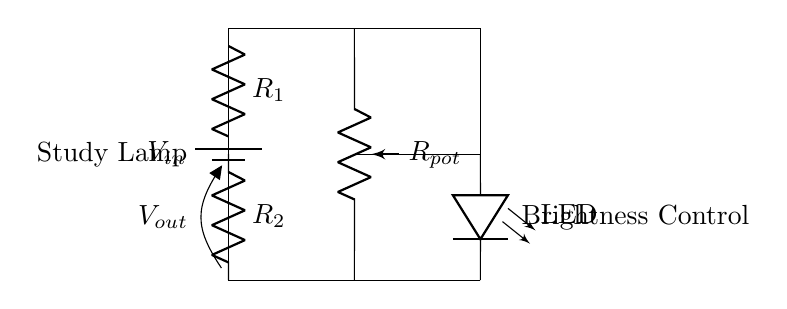What are the resistors in the circuit? The circuit contains two resistors, named R1 and R2, indicated in the diagram.
Answer: R1, R2 What is the role of the potentiometer in this circuit? The potentiometer, labeled Rpot, allows for adjustable resistance, which helps control the brightness of the LED.
Answer: Brightness control What is the output voltage related to? The output voltage, labeled Vout, is the voltage drop across resistor R2 and affects the LED brightness.
Answer: LED brightness How is the LED connected to the circuit? The LED is directly connected to the output of resistor R2, where it receives the adjusted voltage from Vout.
Answer: Parallel What happens if R1 is increased? Increasing R1 will reduce Vout because more voltage drops across R1, resulting in less brightness for the LED.
Answer: Reduced brightness What is the function of the battery in this circuit? The battery provides the input voltage, Vin, necessary to power the entire circuit including the LED.
Answer: Power supply 